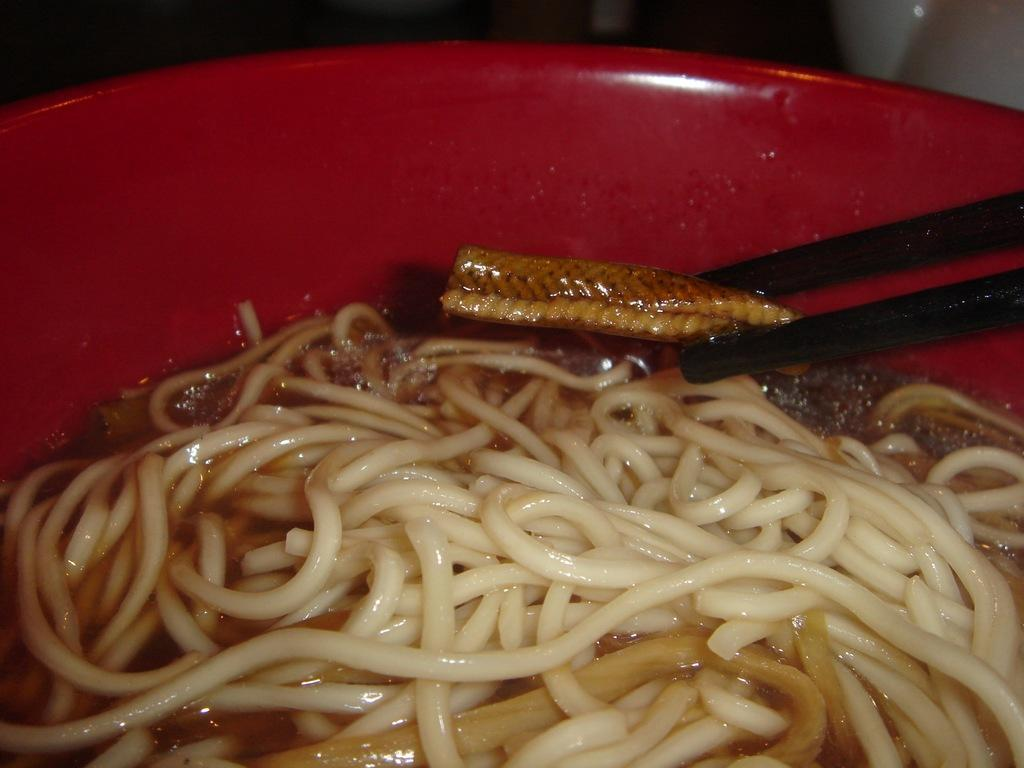What type of food can be seen in the image? There are noodles in the image. How is the food item presented in the image? The food item is on a bowl in the image. What type of fruit is visible in the image? There is no fruit present in the image; it features noodles on a bowl. What type of pancake can be seen in the image? There is no pancake present in the image; it features noodles on a bowl. 